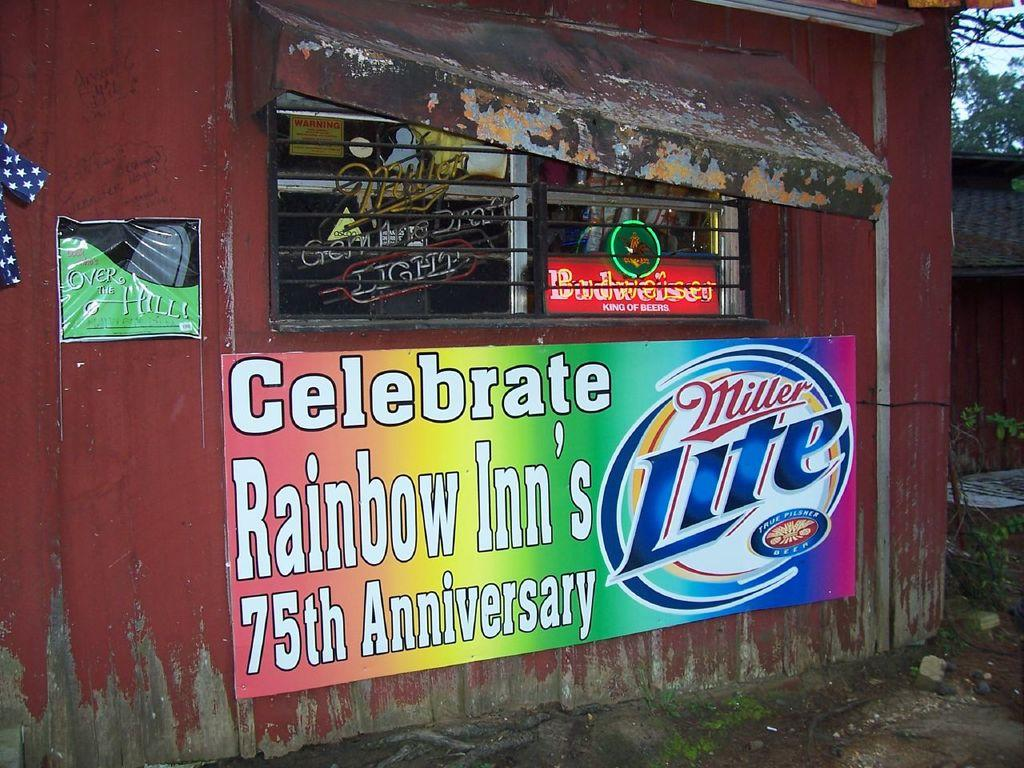<image>
Offer a succinct explanation of the picture presented. a closed corner store with Miller Lite ad saying Celebrate Rainbow Inn's 75th anniversary. 